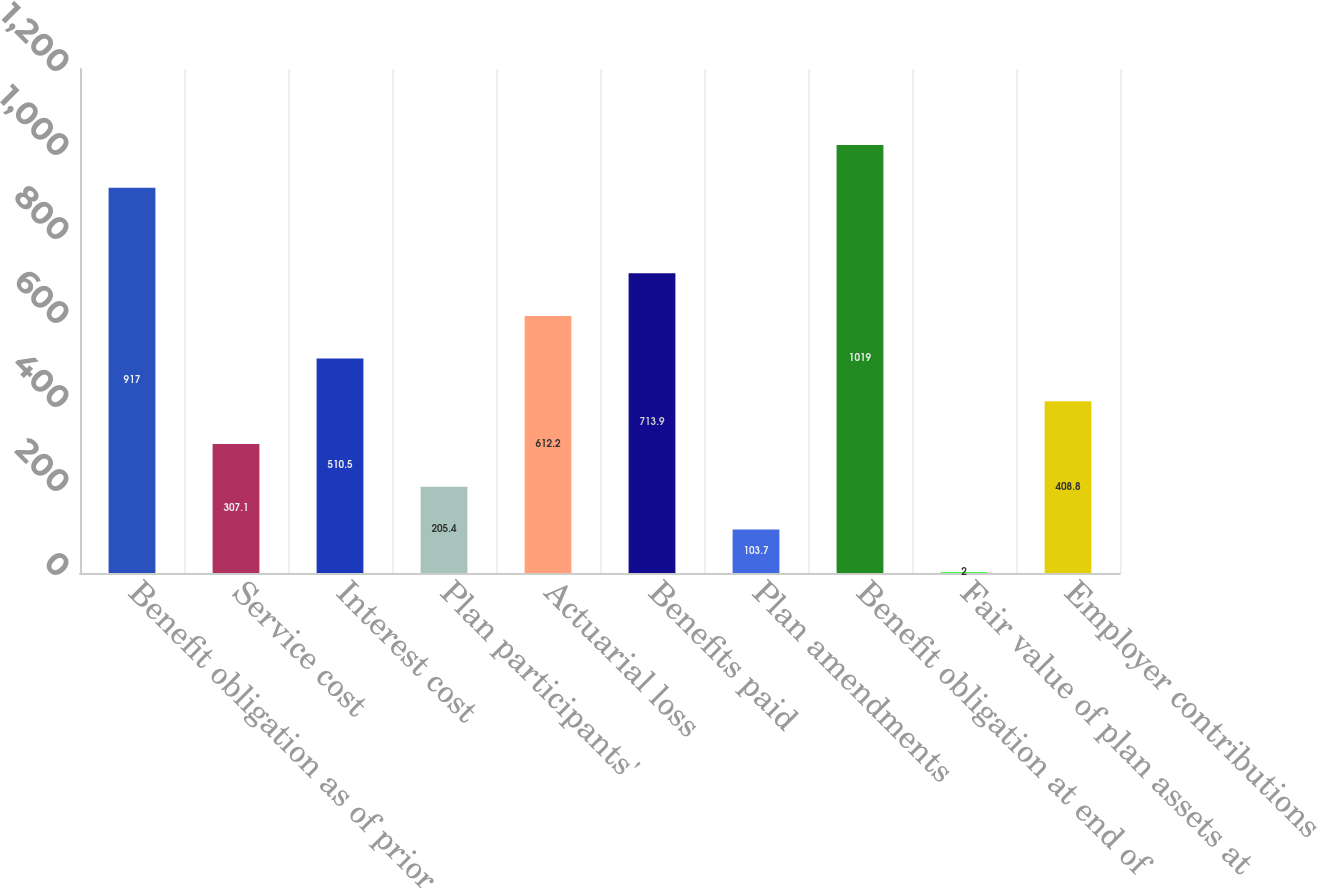Convert chart to OTSL. <chart><loc_0><loc_0><loc_500><loc_500><bar_chart><fcel>Benefit obligation as of prior<fcel>Service cost<fcel>Interest cost<fcel>Plan participants'<fcel>Actuarial loss<fcel>Benefits paid<fcel>Plan amendments<fcel>Benefit obligation at end of<fcel>Fair value of plan assets at<fcel>Employer contributions<nl><fcel>917<fcel>307.1<fcel>510.5<fcel>205.4<fcel>612.2<fcel>713.9<fcel>103.7<fcel>1019<fcel>2<fcel>408.8<nl></chart> 